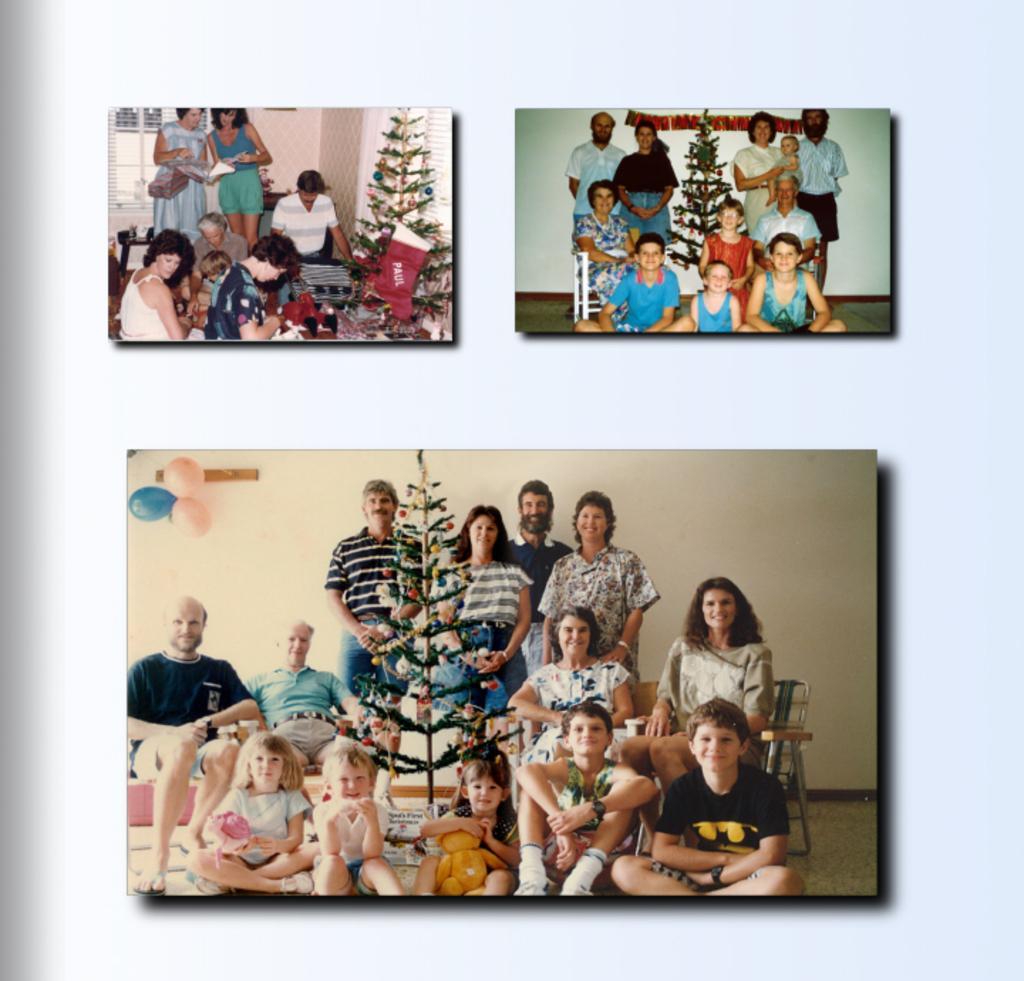In one or two sentences, can you explain what this image depicts? In the image we can see collage photos. In the photos we can see there are people, sitting and some of them are standing, they are wearing clothes. We can even see the Christmas tree, decorations, balloons, wall and the floor. 